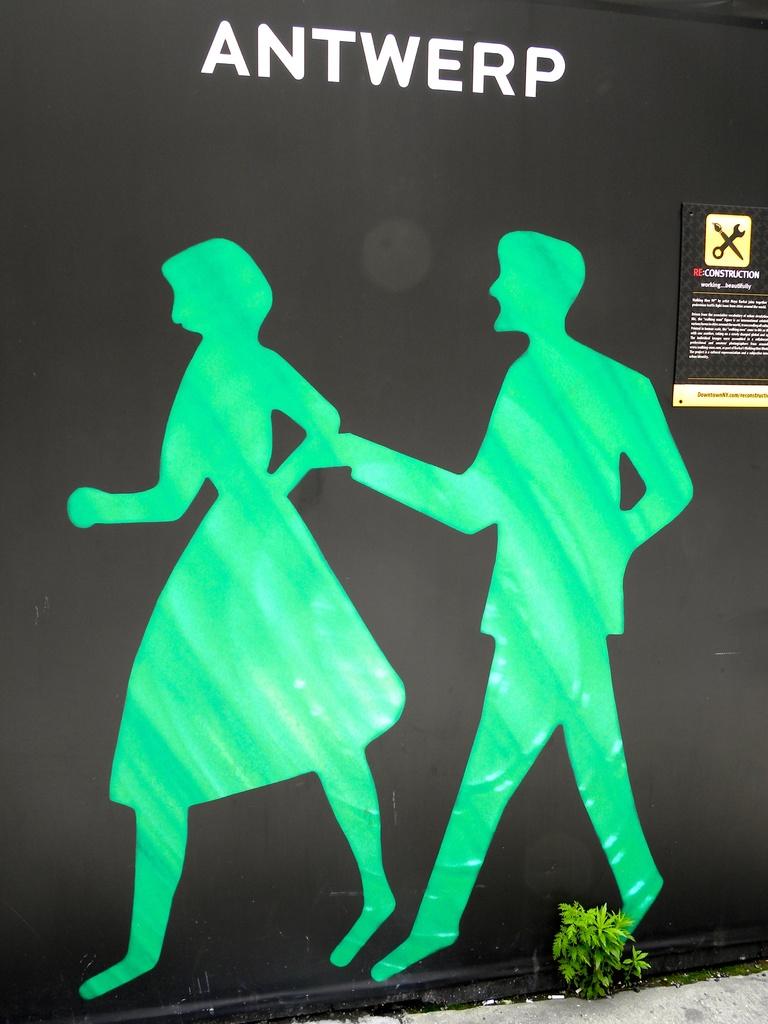What's it say at the top?
Your answer should be compact. Antwerp. 